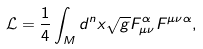Convert formula to latex. <formula><loc_0><loc_0><loc_500><loc_500>\mathcal { L } = \frac { 1 } { 4 } \int _ { M } d ^ { n } x \sqrt { g } F _ { \mu \nu } ^ { \alpha } F ^ { \mu \nu \alpha } ,</formula> 